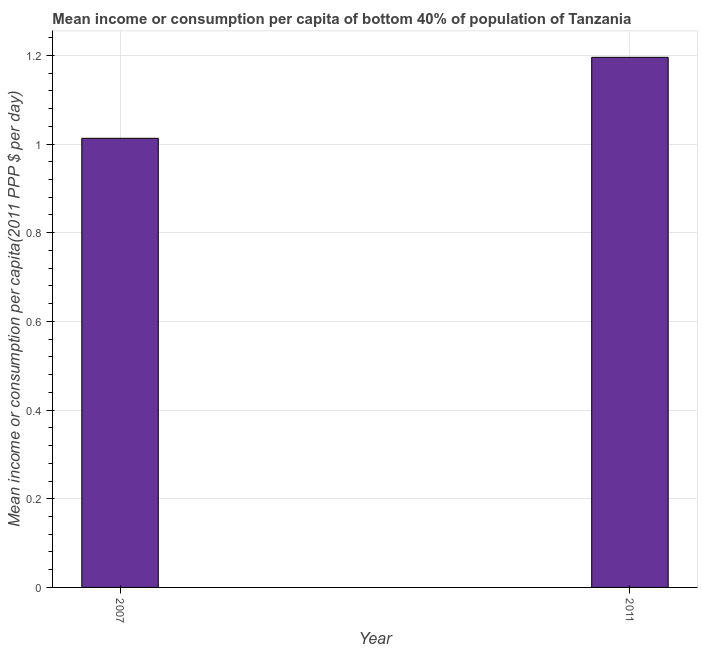Does the graph contain grids?
Offer a very short reply. Yes. What is the title of the graph?
Offer a terse response. Mean income or consumption per capita of bottom 40% of population of Tanzania. What is the label or title of the Y-axis?
Ensure brevity in your answer.  Mean income or consumption per capita(2011 PPP $ per day). What is the mean income or consumption in 2007?
Your answer should be compact. 1.01. Across all years, what is the maximum mean income or consumption?
Provide a short and direct response. 1.2. Across all years, what is the minimum mean income or consumption?
Make the answer very short. 1.01. What is the sum of the mean income or consumption?
Give a very brief answer. 2.21. What is the difference between the mean income or consumption in 2007 and 2011?
Your response must be concise. -0.18. What is the average mean income or consumption per year?
Provide a succinct answer. 1.1. What is the median mean income or consumption?
Give a very brief answer. 1.1. In how many years, is the mean income or consumption greater than 0.4 $?
Your answer should be very brief. 2. Do a majority of the years between 2011 and 2007 (inclusive) have mean income or consumption greater than 0.92 $?
Give a very brief answer. No. What is the ratio of the mean income or consumption in 2007 to that in 2011?
Ensure brevity in your answer.  0.85. Is the mean income or consumption in 2007 less than that in 2011?
Ensure brevity in your answer.  Yes. In how many years, is the mean income or consumption greater than the average mean income or consumption taken over all years?
Keep it short and to the point. 1. How many bars are there?
Ensure brevity in your answer.  2. How many years are there in the graph?
Your response must be concise. 2. What is the difference between two consecutive major ticks on the Y-axis?
Your answer should be compact. 0.2. Are the values on the major ticks of Y-axis written in scientific E-notation?
Keep it short and to the point. No. What is the Mean income or consumption per capita(2011 PPP $ per day) of 2007?
Offer a terse response. 1.01. What is the Mean income or consumption per capita(2011 PPP $ per day) of 2011?
Provide a succinct answer. 1.2. What is the difference between the Mean income or consumption per capita(2011 PPP $ per day) in 2007 and 2011?
Ensure brevity in your answer.  -0.18. What is the ratio of the Mean income or consumption per capita(2011 PPP $ per day) in 2007 to that in 2011?
Your answer should be very brief. 0.85. 